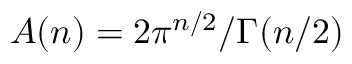Convert formula to latex. <formula><loc_0><loc_0><loc_500><loc_500>A ( n ) = 2 \pi ^ { n / 2 } / \Gamma ( n / 2 )</formula> 